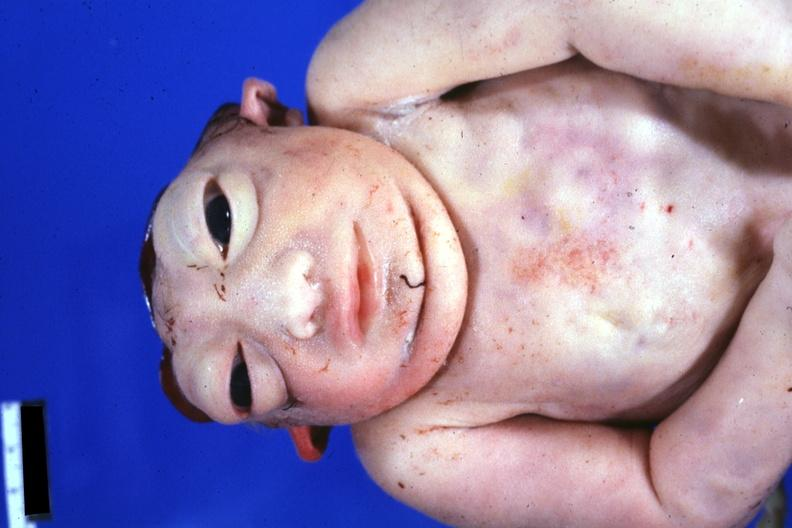s skin over back a buttocks present?
Answer the question using a single word or phrase. No 